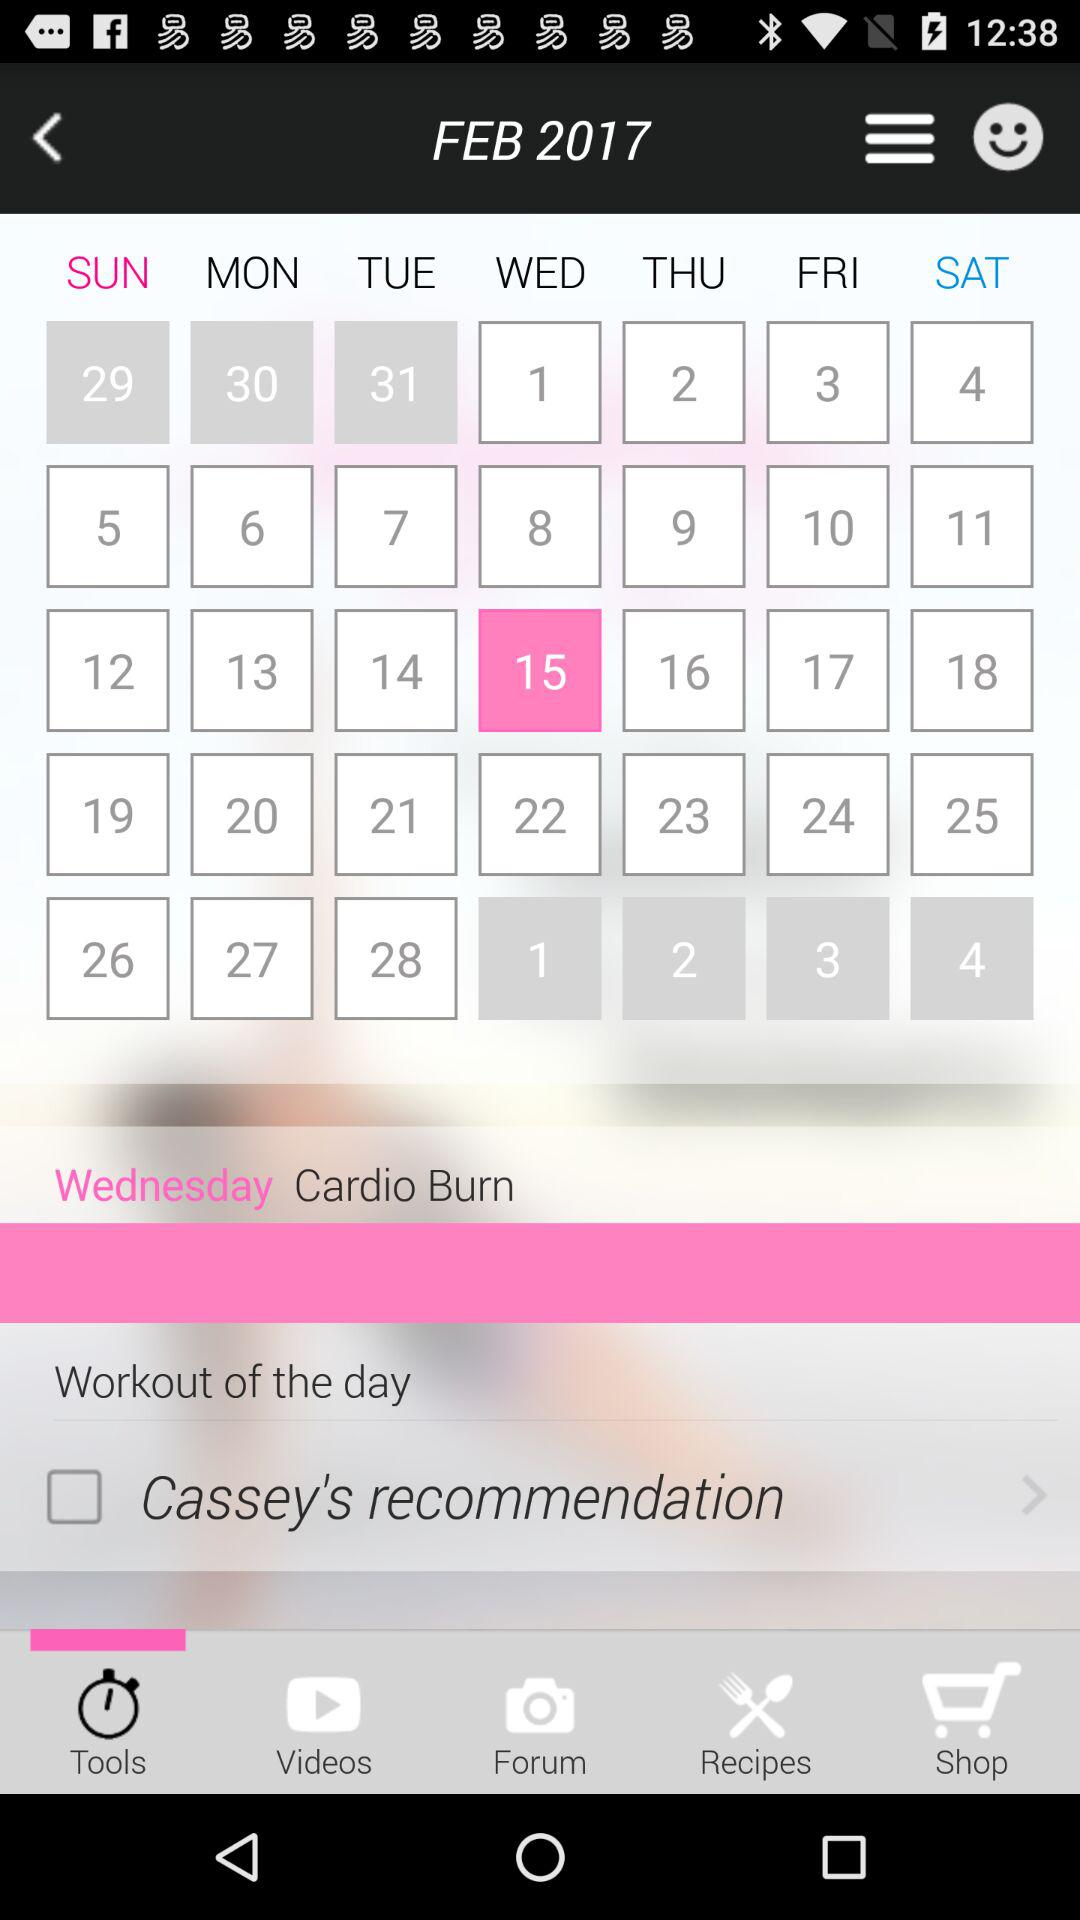What is the selected date? The selected date is Wednesday, February 15, 2017. 